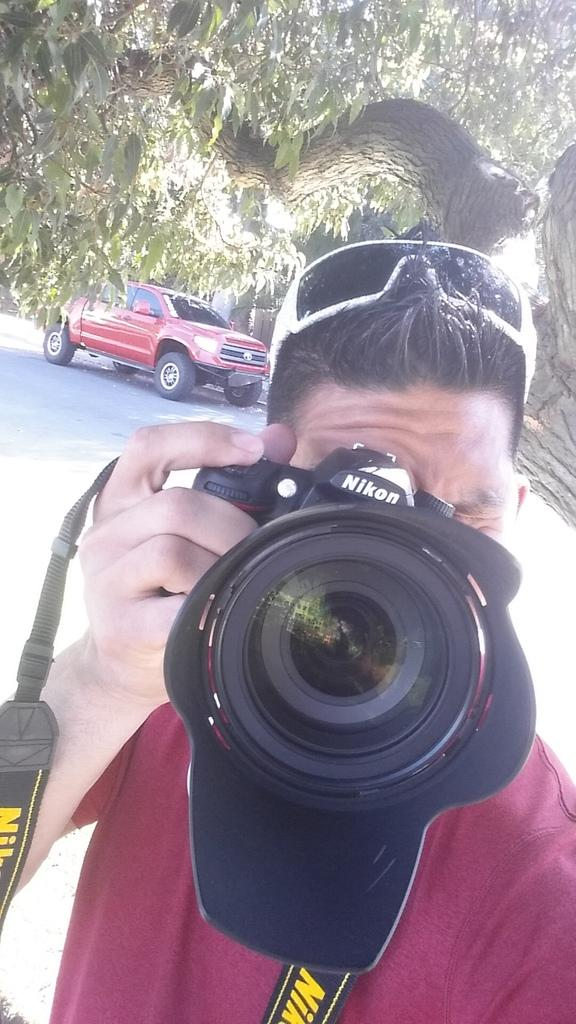What is the main subject of the image? There is a person in the center of the image. What is the person holding in the image? The person is holding a camera. Can you describe the person's appearance? The person is wearing glasses. What can be seen in the background of the image? There is a tree, a road, and a vehicle in the background of the image. Where is the receipt for the camera purchase located in the image? There is no receipt present in the image. What type of development is taking place near the tree in the background? There is no development or construction activity visible in the image; only a tree, a road, and a vehicle can be seen in the background. 